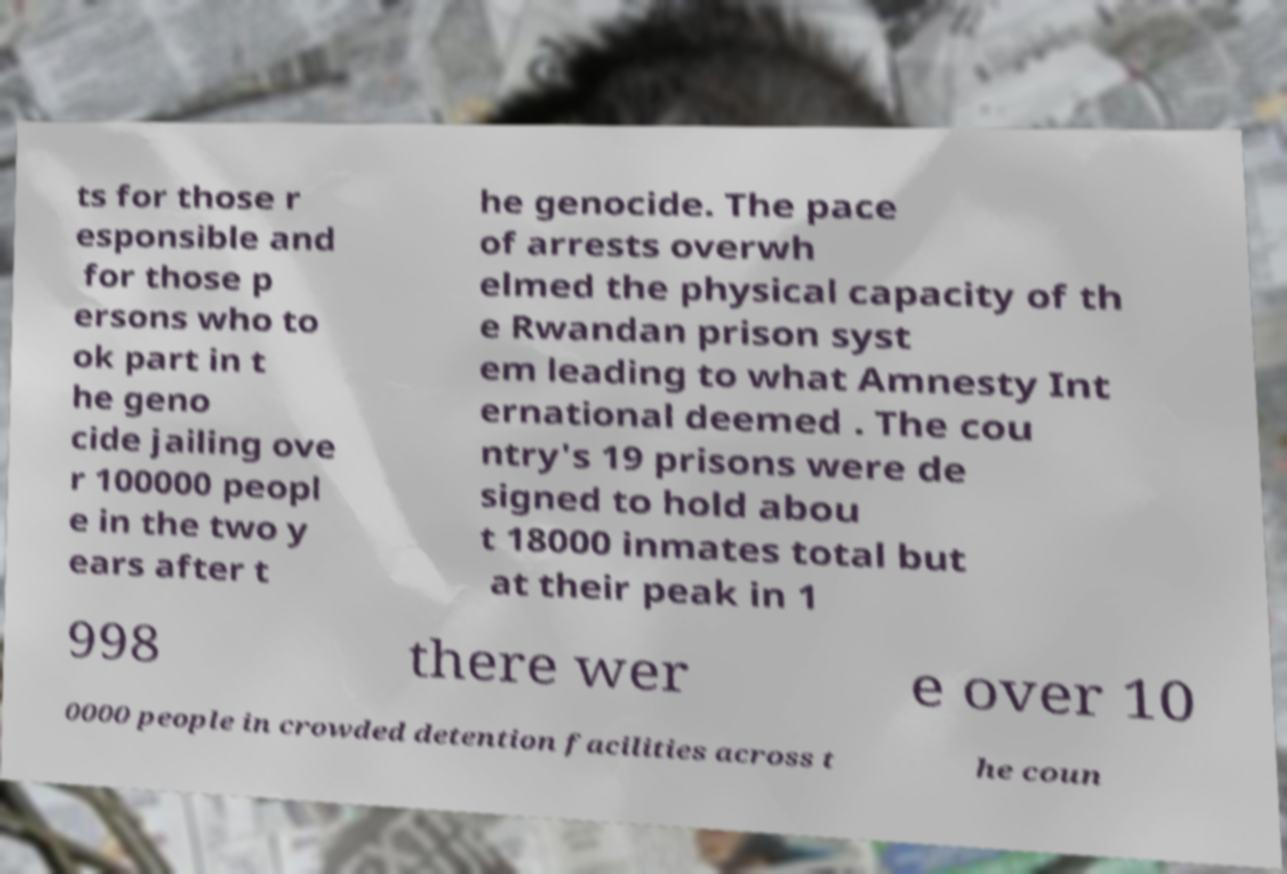I need the written content from this picture converted into text. Can you do that? ts for those r esponsible and for those p ersons who to ok part in t he geno cide jailing ove r 100000 peopl e in the two y ears after t he genocide. The pace of arrests overwh elmed the physical capacity of th e Rwandan prison syst em leading to what Amnesty Int ernational deemed . The cou ntry's 19 prisons were de signed to hold abou t 18000 inmates total but at their peak in 1 998 there wer e over 10 0000 people in crowded detention facilities across t he coun 